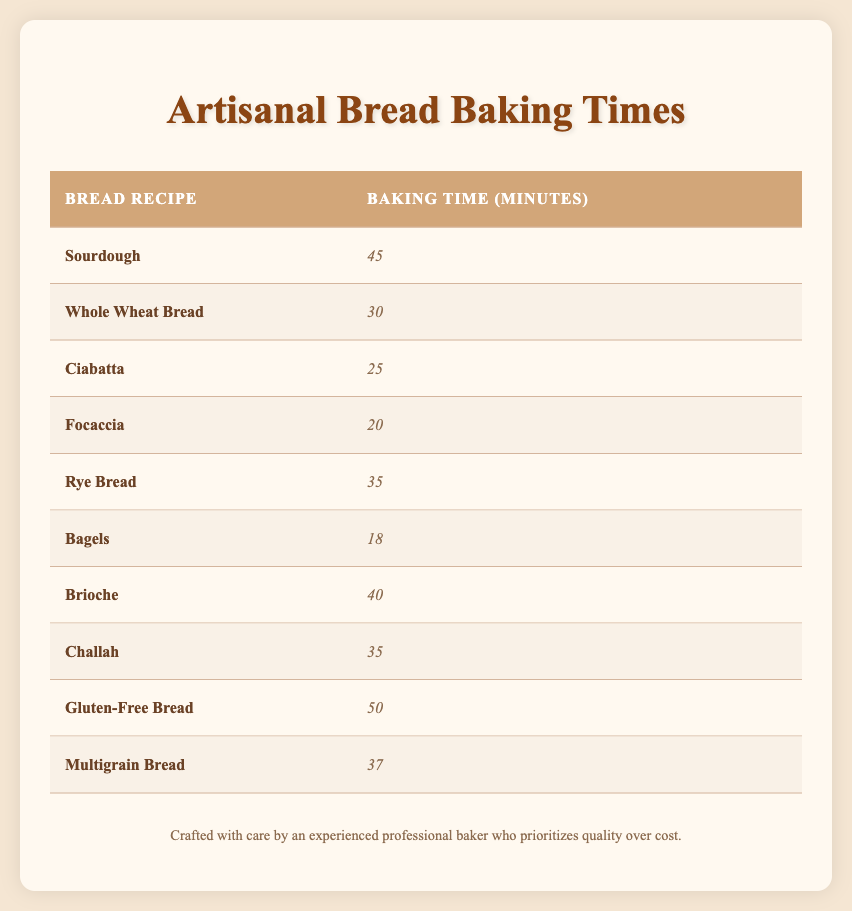What is the baking time for Brioche? The table lists Brioche with a baking time of 40 minutes.
Answer: 40 Which bread has the shortest baking time? Upon reviewing the table, Bagels is listed with the shortest baking time of 18 minutes.
Answer: 18 What is the average baking time for all the bread recipes? By summing all the baking times (45 + 30 + 25 + 20 + 35 + 18 + 40 + 35 + 50 + 37 = 390) and dividing by the number of recipes (10), the average baking time is 390 / 10 = 39 minutes.
Answer: 39 Is Focaccia baked for more than 30 minutes? Focaccia's baking time is 20 minutes, which is less than 30 minutes, so the answer is no.
Answer: No How many recipes have a baking time of 35 minutes or more? The breads with a baking time of 35 minutes or more are Sourdough, Rye Bread, Brioche, Challah, and Gluten-Free Bread. This counts to a total of 5 recipes.
Answer: 5 What is the difference between the longest and shortest baking times? The longest baking time is for Gluten-Free Bread at 50 minutes, and the shortest is for Bagels at 18 minutes. Thus, the difference is 50 - 18 = 32 minutes.
Answer: 32 Can you find a bread recipe that takes more than 40 minutes to bake? The only bread recipe that takes more than 40 minutes to bake is Gluten-Free Bread, which takes 50 minutes. Hence the answer is yes.
Answer: Yes What is the total baking time of Sourdough and Whole Wheat Bread combined? Sourdough takes 45 minutes and Whole Wheat Bread takes 30 minutes, so their total baking time is 45 + 30 = 75 minutes.
Answer: 75 Which two bread recipes have the same baking time? Upon reviewing the table, Rye Bread and Challah both have a baking time of 35 minutes, identifying them as matching recipes.
Answer: Rye Bread and Challah 